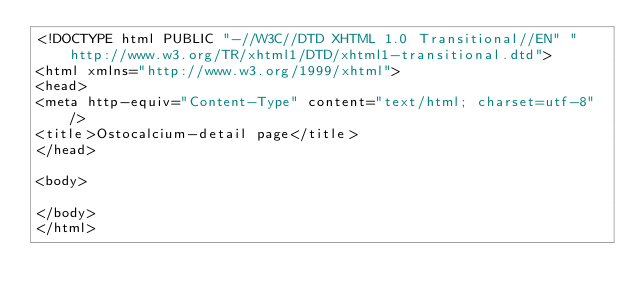<code> <loc_0><loc_0><loc_500><loc_500><_PHP_><!DOCTYPE html PUBLIC "-//W3C//DTD XHTML 1.0 Transitional//EN" "http://www.w3.org/TR/xhtml1/DTD/xhtml1-transitional.dtd">
<html xmlns="http://www.w3.org/1999/xhtml">
<head>
<meta http-equiv="Content-Type" content="text/html; charset=utf-8" />
<title>Ostocalcium-detail page</title>
</head>

<body>

</body>
</html>
</code> 